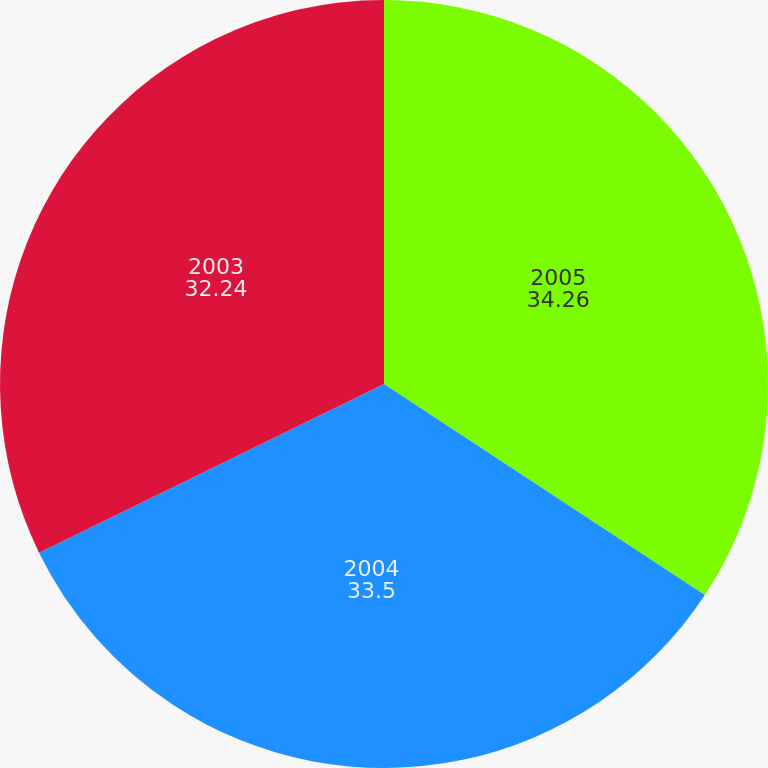<chart> <loc_0><loc_0><loc_500><loc_500><pie_chart><fcel>2005<fcel>2004<fcel>2003<nl><fcel>34.26%<fcel>33.5%<fcel>32.24%<nl></chart> 